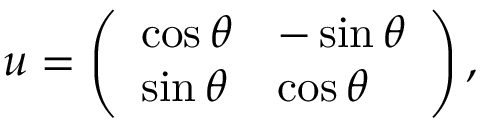Convert formula to latex. <formula><loc_0><loc_0><loc_500><loc_500>\begin{array} { r } { { u } = \left ( \begin{array} { l l } { \cos \theta } & { - \sin \theta } \\ { \sin \theta } & { \cos \theta } \end{array} \right ) , } \end{array}</formula> 